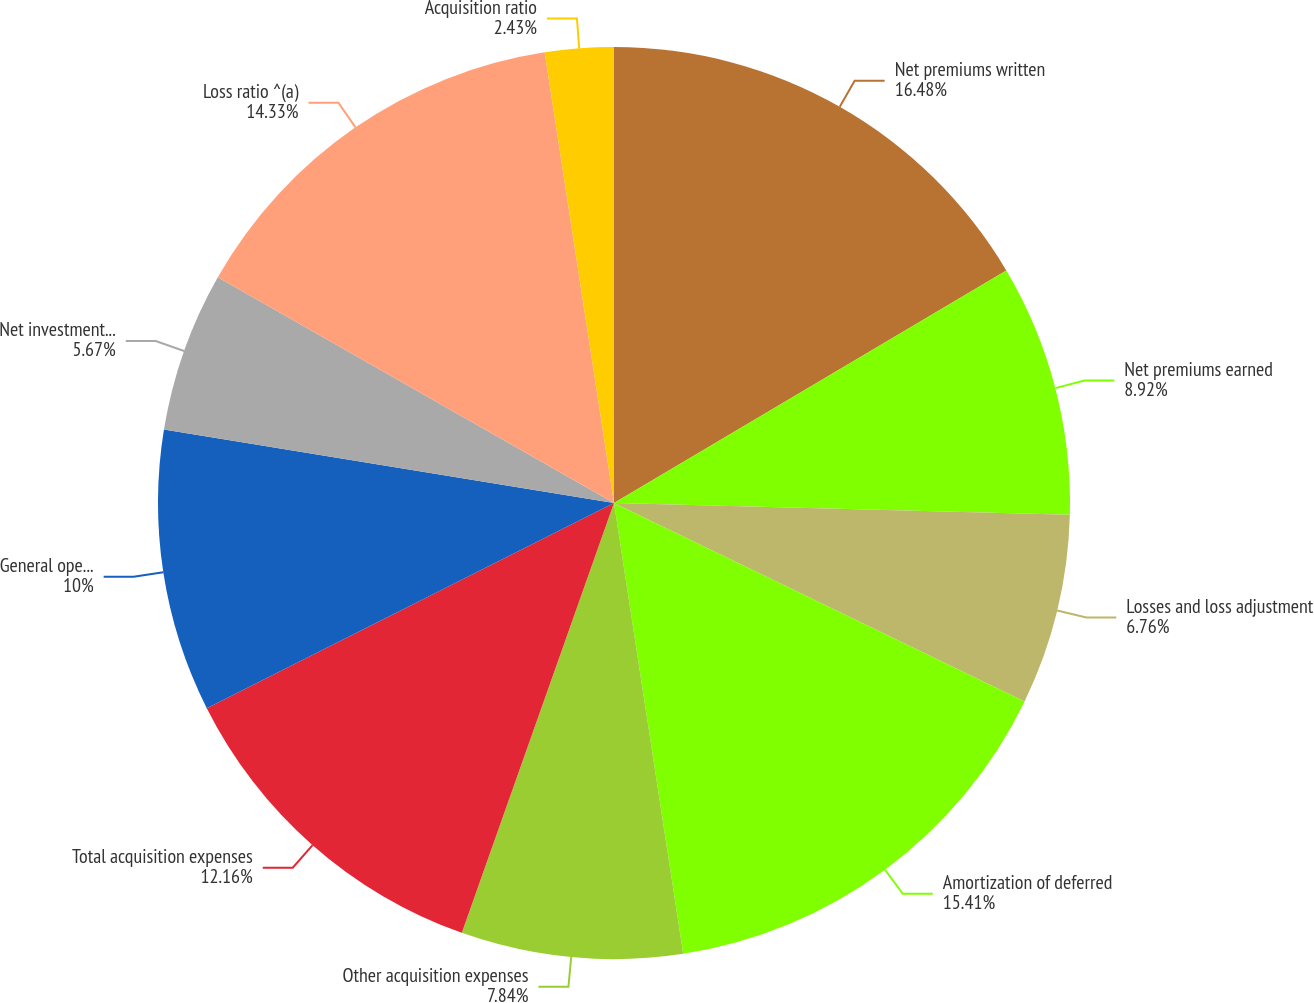Convert chart to OTSL. <chart><loc_0><loc_0><loc_500><loc_500><pie_chart><fcel>Net premiums written<fcel>Net premiums earned<fcel>Losses and loss adjustment<fcel>Amortization of deferred<fcel>Other acquisition expenses<fcel>Total acquisition expenses<fcel>General operating expenses<fcel>Net investment income<fcel>Loss ratio ^(a)<fcel>Acquisition ratio<nl><fcel>16.49%<fcel>8.92%<fcel>6.76%<fcel>15.41%<fcel>7.84%<fcel>12.16%<fcel>10.0%<fcel>5.67%<fcel>14.33%<fcel>2.43%<nl></chart> 